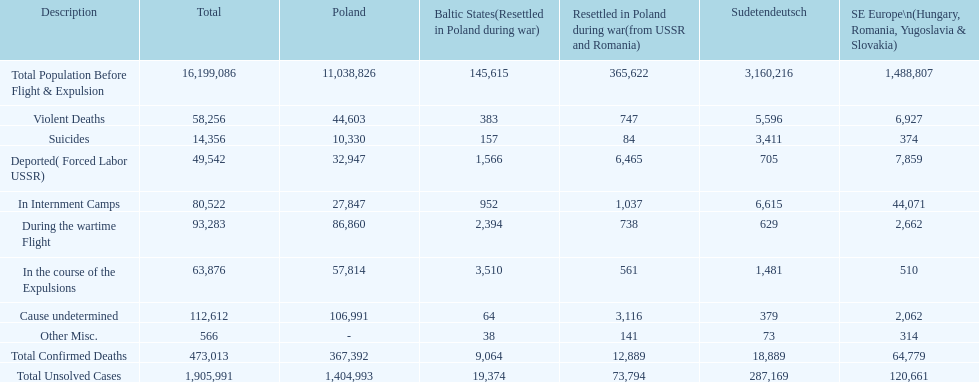What are the complete details? Total Population Before Flight & Expulsion, Violent Deaths, Suicides, Deported( Forced Labor USSR), In Internment Camps, During the wartime Flight, In the course of the Expulsions, Cause undetermined, Other Misc., Total Confirmed Deaths, Total Unsolved Cases. What was the overall number of fatalities? 16,199,086, 58,256, 14,356, 49,542, 80,522, 93,283, 63,876, 112,612, 566, 473,013, 1,905,991. What about solely from aggressive deaths? 58,256. 